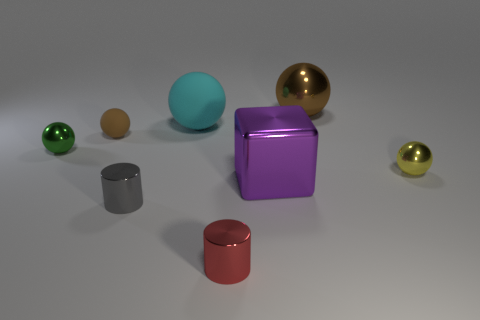How many other things are there of the same size as the yellow metallic object?
Your response must be concise. 4. There is a large metal object that is in front of the metallic thing that is left of the shiny cylinder that is behind the red metallic cylinder; what is its shape?
Give a very brief answer. Cube. There is a tiny object that is behind the cube and in front of the green thing; what shape is it?
Give a very brief answer. Sphere. How many objects are large matte blocks or small objects that are on the right side of the red metallic cylinder?
Offer a very short reply. 1. Are the small gray object and the purple cube made of the same material?
Provide a short and direct response. Yes. How many other objects are the same shape as the small brown matte object?
Offer a terse response. 4. What is the size of the shiny thing that is in front of the tiny green object and on the right side of the purple shiny block?
Offer a terse response. Small. What number of shiny objects are either tiny green objects or big purple cubes?
Offer a very short reply. 2. There is a big metallic thing behind the big metallic cube; does it have the same shape as the tiny thing that is on the right side of the big shiny cube?
Offer a very short reply. Yes. Are there any red objects made of the same material as the purple thing?
Give a very brief answer. Yes. 